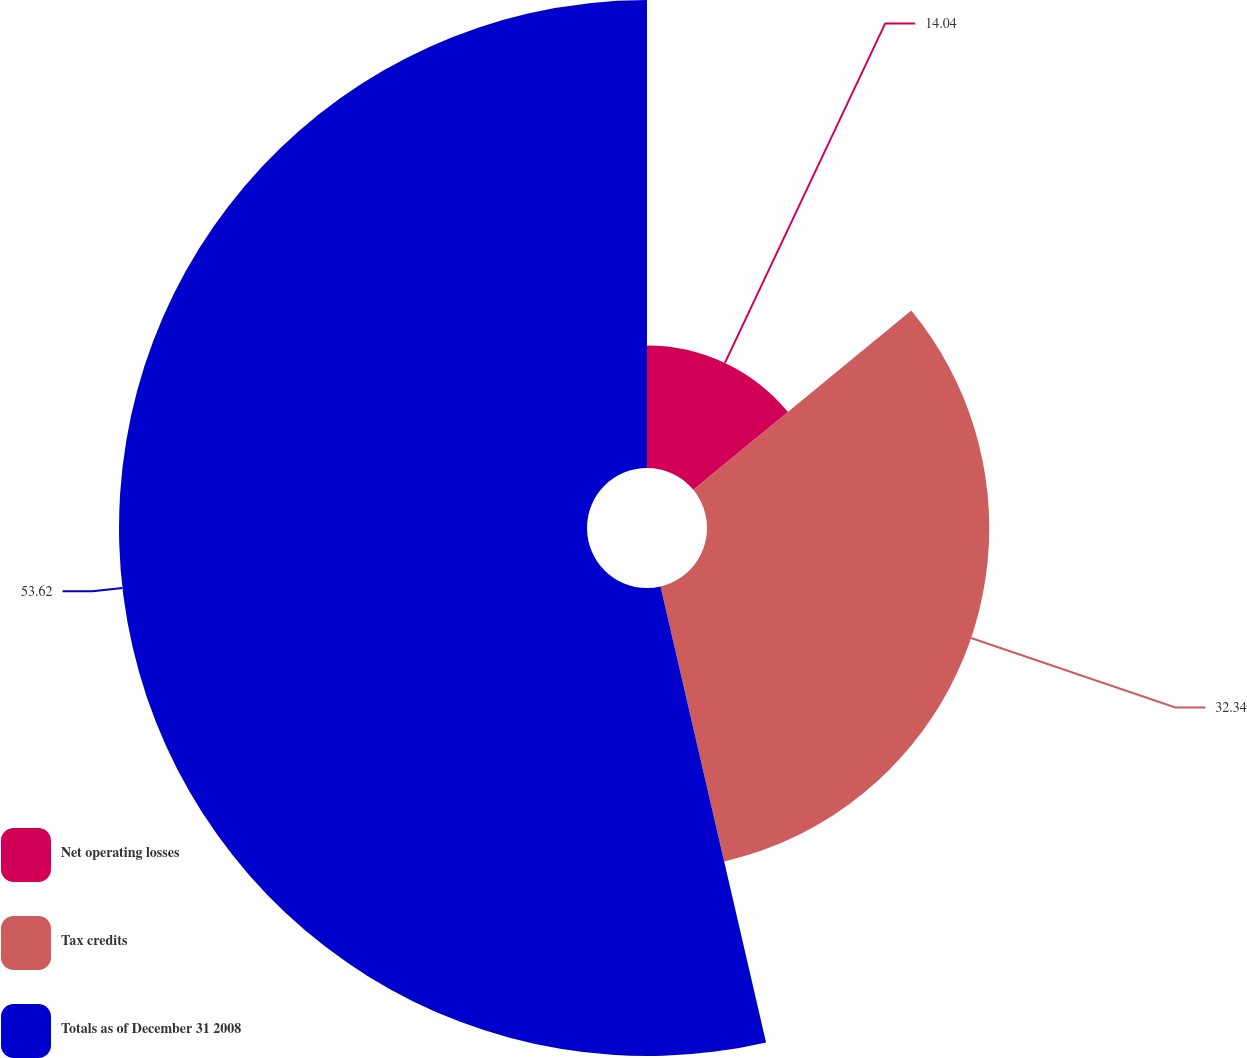Convert chart. <chart><loc_0><loc_0><loc_500><loc_500><pie_chart><fcel>Net operating losses<fcel>Tax credits<fcel>Totals as of December 31 2008<nl><fcel>14.04%<fcel>32.34%<fcel>53.62%<nl></chart> 